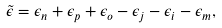Convert formula to latex. <formula><loc_0><loc_0><loc_500><loc_500>\tilde { \epsilon } = \epsilon _ { n } + \epsilon _ { p } + \epsilon _ { o } - \epsilon _ { j } - \epsilon _ { i } - \epsilon _ { m } ,</formula> 